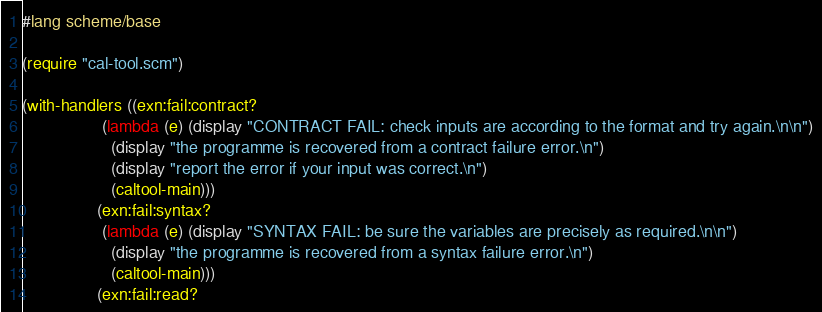<code> <loc_0><loc_0><loc_500><loc_500><_Scheme_>#lang scheme/base

(require "cal-tool.scm")

(with-handlers ((exn:fail:contract?
                 (lambda (e) (display "CONTRACT FAIL: check inputs are according to the format and try again.\n\n")
                   (display "the programme is recovered from a contract failure error.\n")
                   (display "report the error if your input was correct.\n")
                   (caltool-main)))
                (exn:fail:syntax?
                 (lambda (e) (display "SYNTAX FAIL: be sure the variables are precisely as required.\n\n")
                   (display "the programme is recovered from a syntax failure error.\n")
                   (caltool-main)))
                (exn:fail:read?</code> 